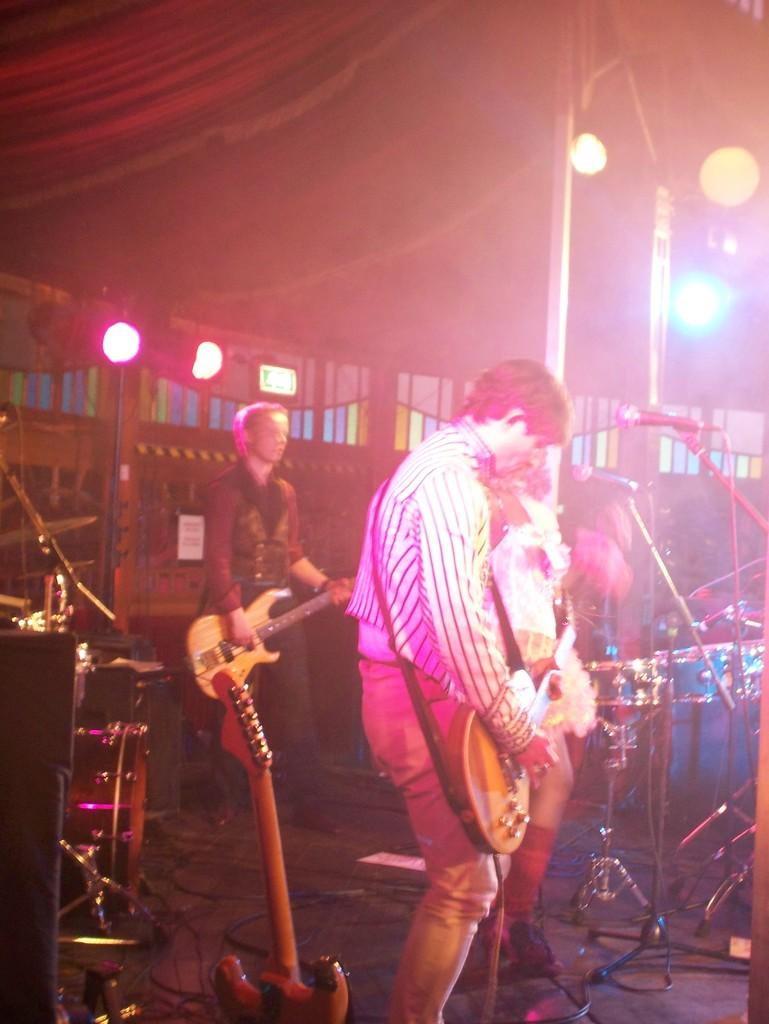How many people are in the image? There are people in the image. Where are the people located in the image? The people are standing under a tent. What activity are the people engaged in? The people are playing a guitar. What type of fork can be seen being used by the people in the image? There is no fork present in the image; the people are playing a guitar. What emotion can be observed on the faces of the people in the image? The provided facts do not mention the emotions of the people in the image. --- 